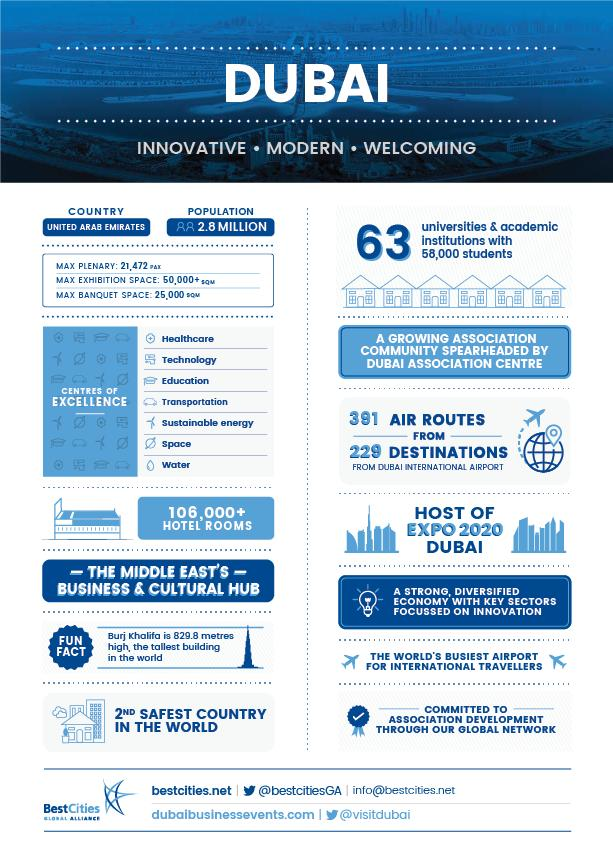Specify some key components in this picture. There are 7 centers of excellence in Dubai. 